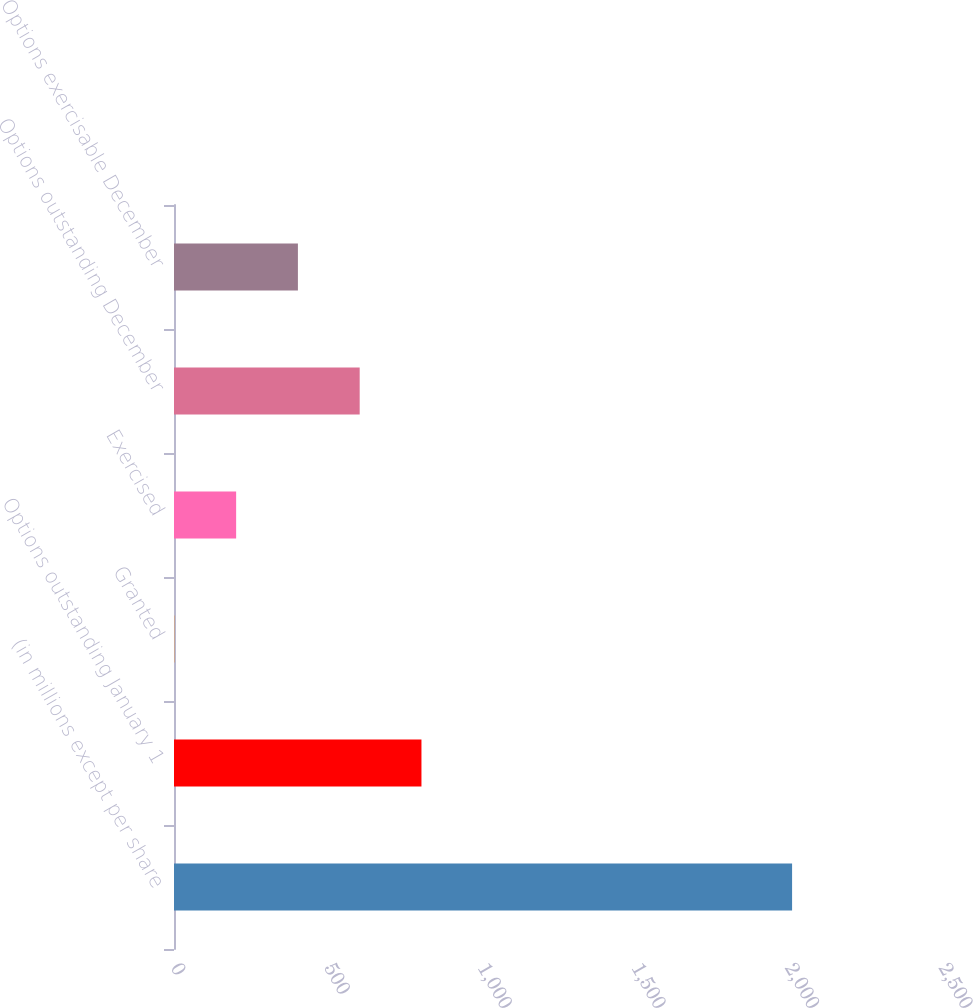Convert chart to OTSL. <chart><loc_0><loc_0><loc_500><loc_500><bar_chart><fcel>(in millions except per share<fcel>Options outstanding January 1<fcel>Granted<fcel>Exercised<fcel>Options outstanding December<fcel>Options exercisable December<nl><fcel>2012<fcel>805.52<fcel>1.2<fcel>202.28<fcel>604.44<fcel>403.36<nl></chart> 